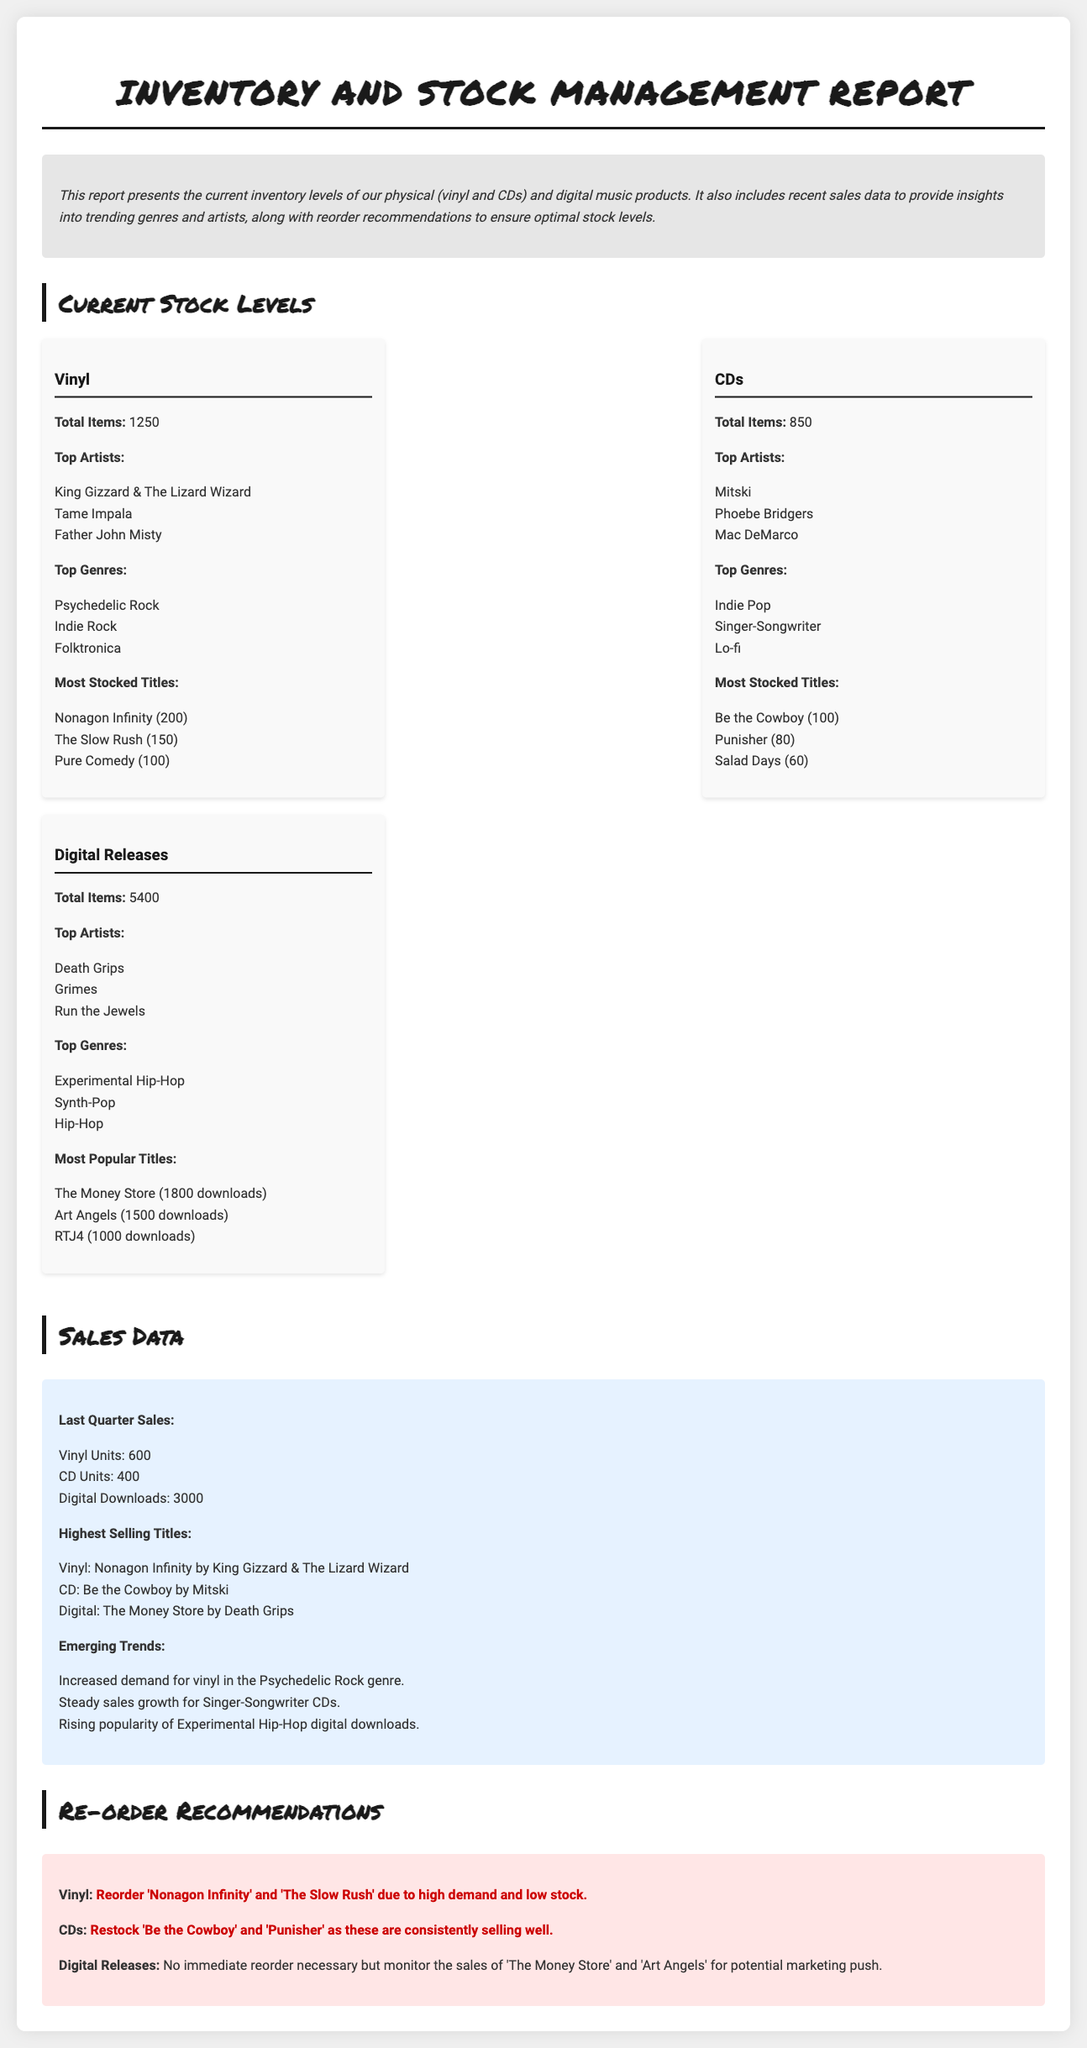What is the total number of vinyl items? The document states that there are 1250 total vinyl items.
Answer: 1250 Who is the top artist for CDs? The document lists Mitski as the top artist for CDs.
Answer: Mitski What is the most popular digital title by download count? The document indicates that The Money Store is the most popular digital title with 1800 downloads.
Answer: The Money Store How many vinyl units were sold last quarter? According to the document, 600 vinyl units were sold last quarter.
Answer: 600 Which genre shows increased demand for vinyl? The document mentions that there is increased demand for vinyl in the Psychedelic Rock genre.
Answer: Psychedelic Rock What is the reorder recommendation for CDs? The document recommends restocking Be the Cowboy and Punisher for CDs.
Answer: Be the Cowboy and Punisher Which title had the highest sales in digital downloads? The document states that The Money Store had the highest sales in digital downloads.
Answer: The Money Store What is the total number of digital releases? The document specifies that there are 5400 total digital releases.
Answer: 5400 What genre is associated with the highest selling vinyl title? The highest selling vinyl title, Nonagon Infinity, is associated with the Psychedelic Rock genre.
Answer: Psychedelic Rock 